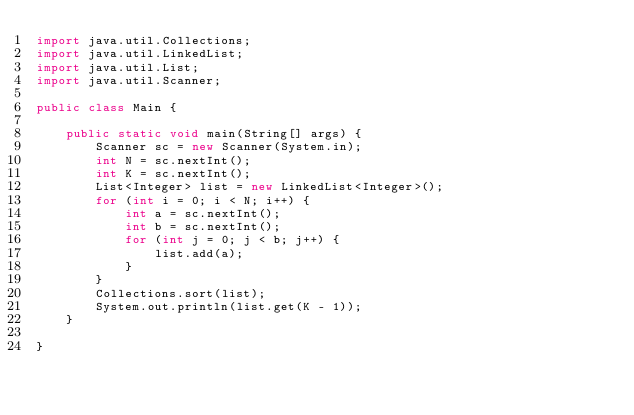<code> <loc_0><loc_0><loc_500><loc_500><_Java_>import java.util.Collections;
import java.util.LinkedList;
import java.util.List;
import java.util.Scanner;

public class Main {

	public static void main(String[] args) {
		Scanner sc = new Scanner(System.in);
		int N = sc.nextInt();
		int K = sc.nextInt();
		List<Integer> list = new LinkedList<Integer>();
		for (int i = 0; i < N; i++) {
			int a = sc.nextInt();
			int b = sc.nextInt();
			for (int j = 0; j < b; j++) {
				list.add(a);
			}
		}
		Collections.sort(list);
		System.out.println(list.get(K - 1));
	}

}</code> 